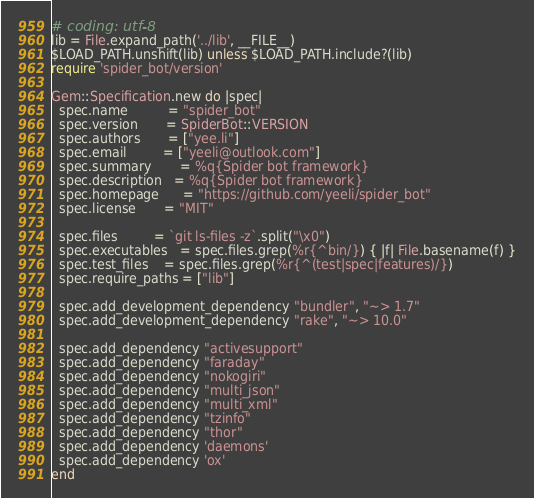<code> <loc_0><loc_0><loc_500><loc_500><_Ruby_># coding: utf-8
lib = File.expand_path('../lib', __FILE__)
$LOAD_PATH.unshift(lib) unless $LOAD_PATH.include?(lib)
require 'spider_bot/version'

Gem::Specification.new do |spec|
  spec.name          = "spider_bot"
  spec.version       = SpiderBot::VERSION
  spec.authors       = ["yee.li"]
  spec.email         = ["yeeli@outlook.com"]
  spec.summary       = %q{Spider bot framework}
  spec.description   = %q{Spider bot framework}
  spec.homepage      = "https://github.com/yeeli/spider_bot"
  spec.license       = "MIT"

  spec.files         = `git ls-files -z`.split("\x0")
  spec.executables   = spec.files.grep(%r{^bin/}) { |f| File.basename(f) }
  spec.test_files    = spec.files.grep(%r{^(test|spec|features)/})
  spec.require_paths = ["lib"]

  spec.add_development_dependency "bundler", "~> 1.7"
  spec.add_development_dependency "rake", "~> 10.0"

  spec.add_dependency "activesupport"
  spec.add_dependency "faraday"
  spec.add_dependency "nokogiri"
  spec.add_dependency "multi_json"
  spec.add_dependency "multi_xml"
  spec.add_dependency "tzinfo"
  spec.add_dependency "thor"
  spec.add_dependency 'daemons'
  spec.add_dependency 'ox'
end
</code> 